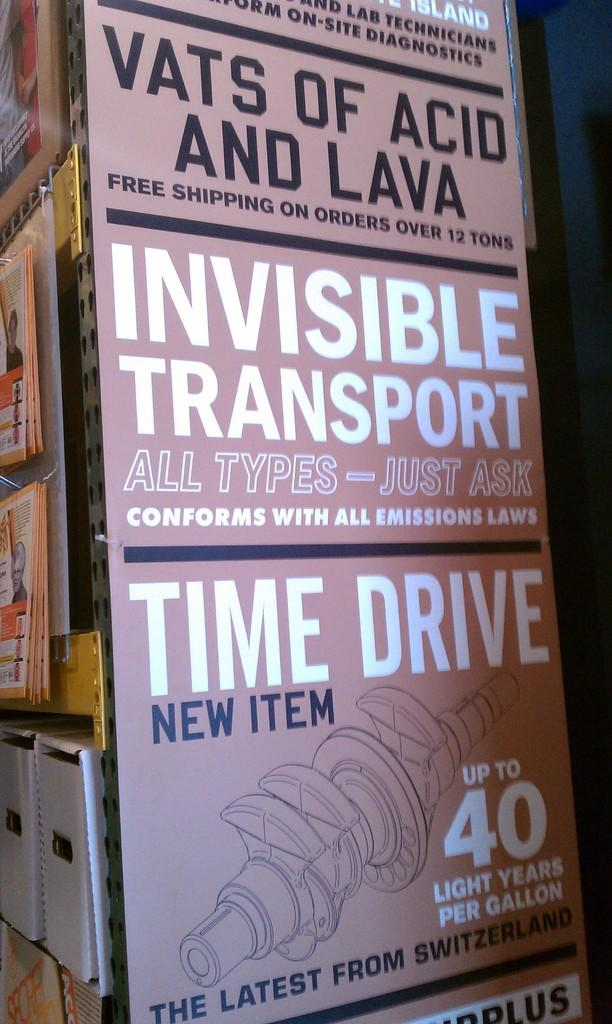<image>
Write a terse but informative summary of the picture. A poster advertising vats of lava and acid. 